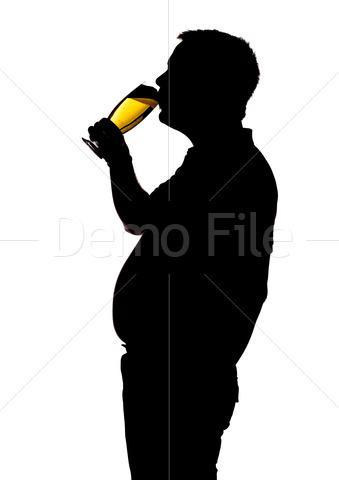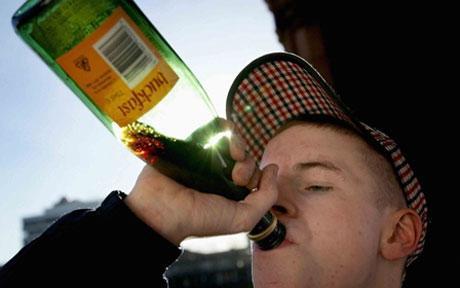The first image is the image on the left, the second image is the image on the right. Considering the images on both sides, is "In at least one image there is a single male silhouette drink a glass of beer." valid? Answer yes or no. Yes. The first image is the image on the left, the second image is the image on the right. Examine the images to the left and right. Is the description "Two men are drinking and holding their beverage towards the left side of the image." accurate? Answer yes or no. Yes. 